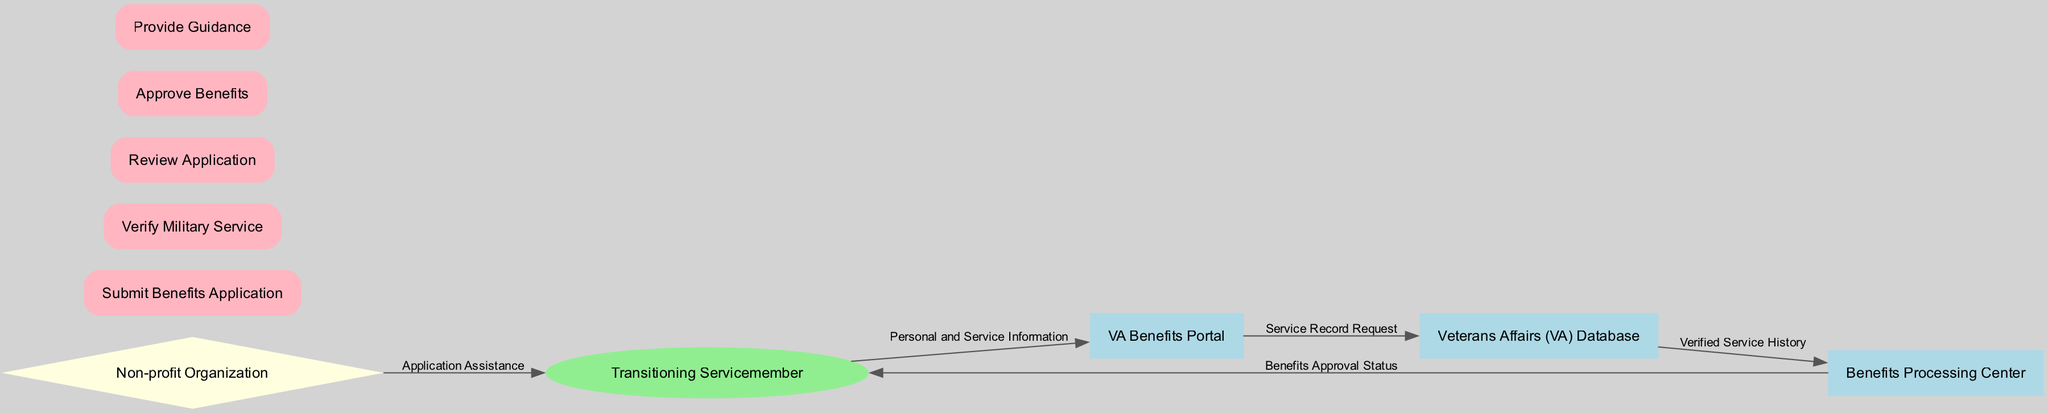What entities are involved in the benefits application system? The entities listed in the diagram include Transitioning Servicemember, VA Benefits Portal, Non-profit Organization, Veterans Affairs Database, and Benefits Processing Center.
Answer: Transitioning Servicemember, VA Benefits Portal, Non-profit Organization, Veterans Affairs Database, Benefits Processing Center How many processes are there in the diagram? The diagram has five processes: Submit Benefits Application, Verify Military Service, Review Application, Approve Benefits, and Provide Guidance. Counting these processes results in a total of five.
Answer: 5 What data flows from the Non-profit Organization to the Transitioning Servicemember? The data flow from the Non-profit Organization to the Transitioning Servicemember is labeled "Application Assistance." This indicates that the non-profit provides assistance regarding the application process to the servicemember.
Answer: Application Assistance Which process is responsible for the "Verified Service History"? The "Verified Service History" is handled by the Benefits Processing Center as indicated by the data flow coming from the Veterans Affairs (VA) Database to the Benefits Processing Center. This confirms that the processing center receives the verified records for further action.
Answer: Benefits Processing Center What type of entity is the Non-profit Organization in the diagram? The Non-profit Organization is represented as a diamond shape in the diagram, which is commonly used to denote special types of entities in data flow diagrams, here indicating its role in providing support.
Answer: Diamond Which entity receives the "Benefits Approval Status"? The "Benefits Approval Status" is sent to the Transitioning Servicemember from the Benefits Processing Center, as noted by the directed data flow. This places the servicemember as the recipient of approval information.
Answer: Transitioning Servicemember What is the first step in the process of applying for benefits? The first step is the "Submit Benefits Application," which is initiated by the Transitioning Servicemember as the starting point of the application process. This serves as the foundation for the subsequent verification and approval steps.
Answer: Submit Benefits Application How does the VA Benefits Portal relate to the Veterans Affairs Database? The VA Benefits Portal sends a "Service Record Request" to the Veterans Affairs Database, indicating a request for accessing the servicemember's service history, which is crucial for the approval process. This flow underscores the importance of service verification.
Answer: Service Record Request What is the flow direction of data from the Benefits Processing Center? The Benefits Processing Center flows data towards the Transitioning Servicemember, specifically sending the "Benefits Approval Status." This one-way flow highlights the center's role in communicating final decisions back to the applicant.
Answer: Transitioning Servicemember 